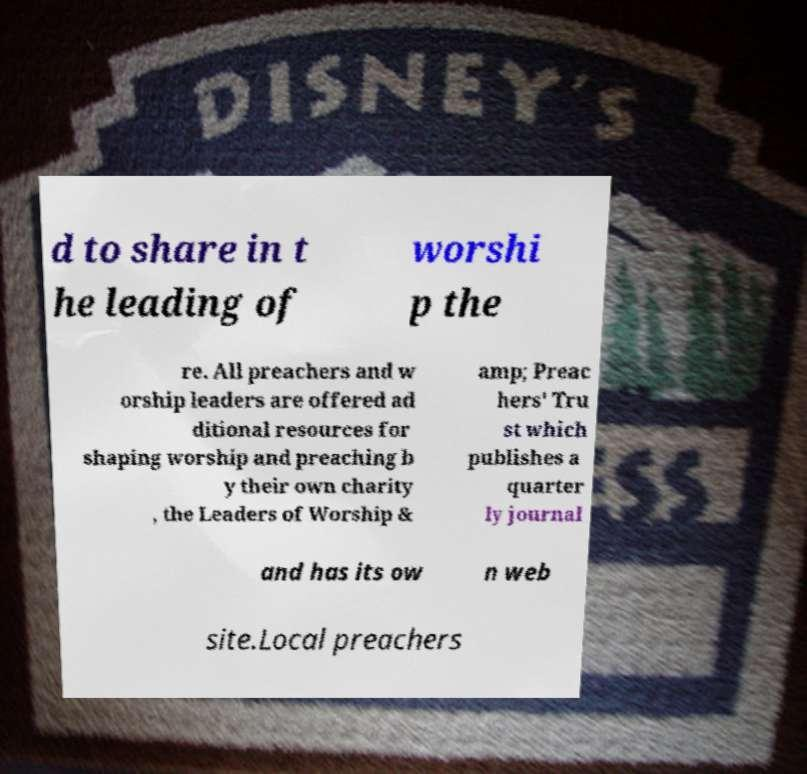Could you extract and type out the text from this image? d to share in t he leading of worshi p the re. All preachers and w orship leaders are offered ad ditional resources for shaping worship and preaching b y their own charity , the Leaders of Worship & amp; Preac hers' Tru st which publishes a quarter ly journal and has its ow n web site.Local preachers 